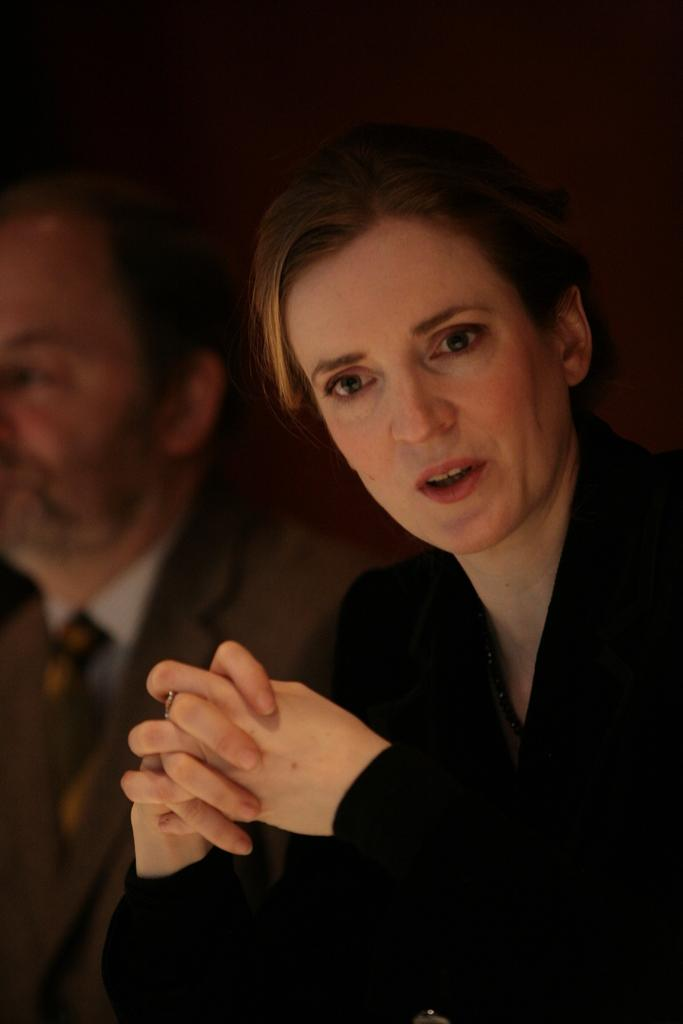Who is present in the image? There is a man and a woman in the image. What is the man wearing? The man is wearing a suit. What is the woman wearing? The woman is wearing a black dress. What type of flowers can be seen on the woman's dress in the image? There are no flowers visible on the woman's dress in the image; she is wearing a black dress. What substance is the man holding in the image? There is no substance visible in the man's hands in the image; he is simply wearing a suit. 